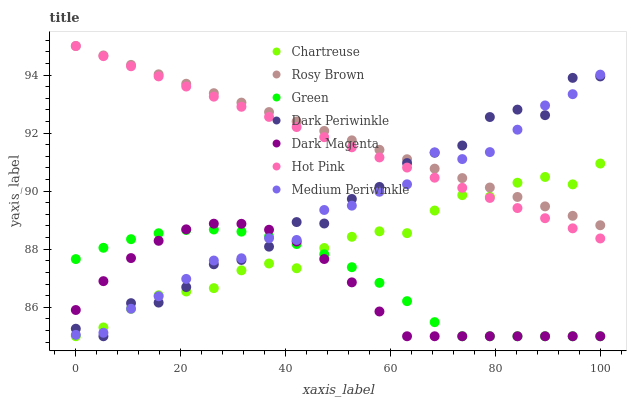Does Dark Magenta have the minimum area under the curve?
Answer yes or no. Yes. Does Rosy Brown have the maximum area under the curve?
Answer yes or no. Yes. Does Rosy Brown have the minimum area under the curve?
Answer yes or no. No. Does Dark Magenta have the maximum area under the curve?
Answer yes or no. No. Is Rosy Brown the smoothest?
Answer yes or no. Yes. Is Dark Periwinkle the roughest?
Answer yes or no. Yes. Is Dark Magenta the smoothest?
Answer yes or no. No. Is Dark Magenta the roughest?
Answer yes or no. No. Does Dark Magenta have the lowest value?
Answer yes or no. Yes. Does Rosy Brown have the lowest value?
Answer yes or no. No. Does Rosy Brown have the highest value?
Answer yes or no. Yes. Does Dark Magenta have the highest value?
Answer yes or no. No. Is Dark Magenta less than Rosy Brown?
Answer yes or no. Yes. Is Rosy Brown greater than Dark Magenta?
Answer yes or no. Yes. Does Green intersect Dark Periwinkle?
Answer yes or no. Yes. Is Green less than Dark Periwinkle?
Answer yes or no. No. Is Green greater than Dark Periwinkle?
Answer yes or no. No. Does Dark Magenta intersect Rosy Brown?
Answer yes or no. No. 